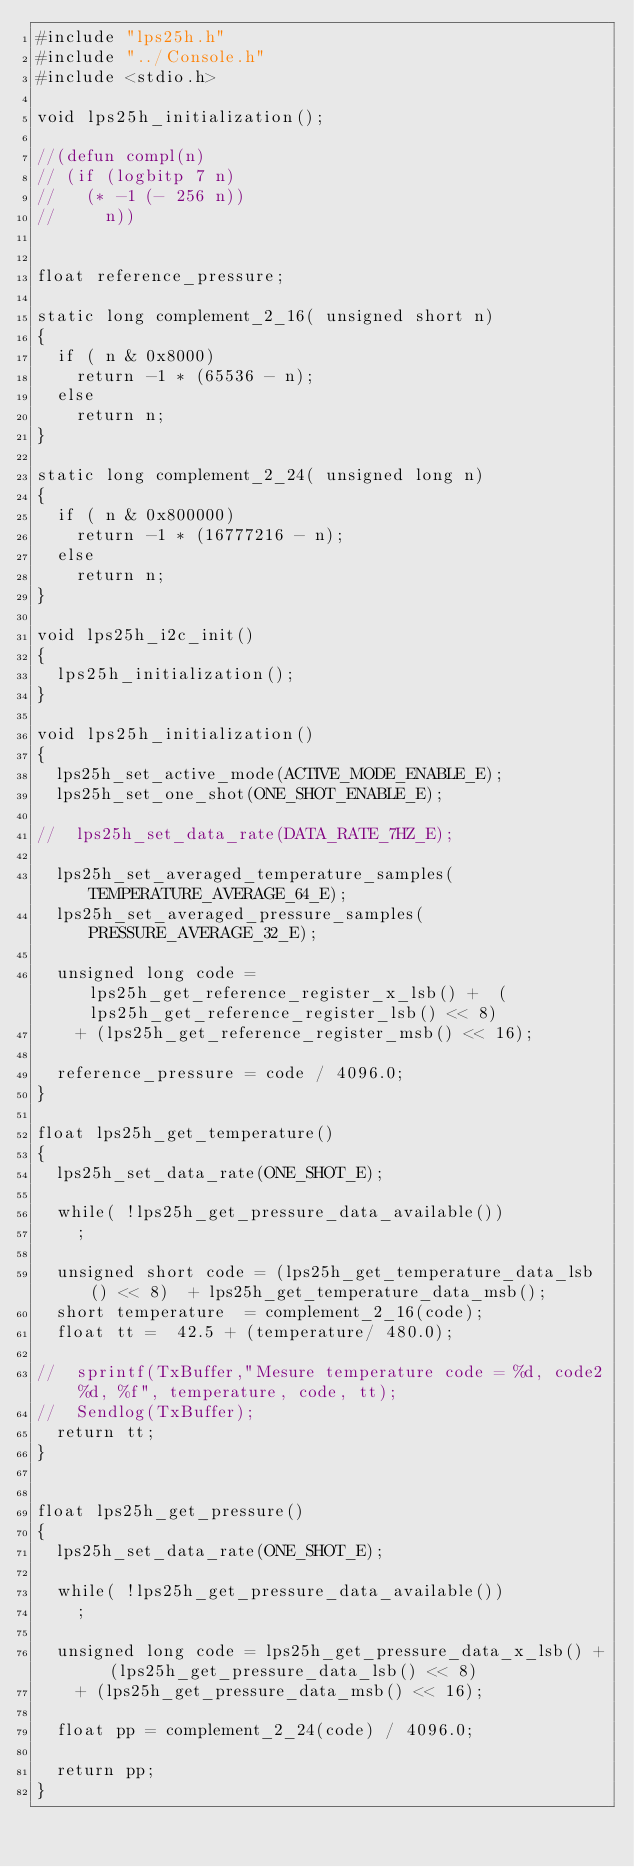Convert code to text. <code><loc_0><loc_0><loc_500><loc_500><_C_>#include "lps25h.h"
#include "../Console.h"
#include <stdio.h>

void lps25h_initialization();

//(defun compl(n)
// (if (logbitp 7 n)
//   (* -1 (- 256 n))
//     n))


float reference_pressure;

static long complement_2_16( unsigned short n)
{
  if ( n & 0x8000)
    return -1 * (65536 - n);
  else
    return n;
}

static long complement_2_24( unsigned long n)
{
  if ( n & 0x800000)
    return -1 * (16777216 - n);
  else
    return n;
}

void lps25h_i2c_init()
{
  lps25h_initialization();
}

void lps25h_initialization()
{
  lps25h_set_active_mode(ACTIVE_MODE_ENABLE_E);
  lps25h_set_one_shot(ONE_SHOT_ENABLE_E);

//  lps25h_set_data_rate(DATA_RATE_7HZ_E);

  lps25h_set_averaged_temperature_samples(TEMPERATURE_AVERAGE_64_E);
  lps25h_set_averaged_pressure_samples(PRESSURE_AVERAGE_32_E);
 
  unsigned long code = lps25h_get_reference_register_x_lsb() +  (lps25h_get_reference_register_lsb() << 8)
    + (lps25h_get_reference_register_msb() << 16);

  reference_pressure = code / 4096.0;
}

float lps25h_get_temperature()
{
  lps25h_set_data_rate(ONE_SHOT_E);

  while( !lps25h_get_pressure_data_available())
    ;

  unsigned short code = (lps25h_get_temperature_data_lsb() << 8)  + lps25h_get_temperature_data_msb();
  short temperature  = complement_2_16(code);
  float tt =  42.5 + (temperature/ 480.0);

//  sprintf(TxBuffer,"Mesure temperature code = %d, code2 %d, %f", temperature, code, tt);
//  Sendlog(TxBuffer); 
  return tt;
}


float lps25h_get_pressure()
{
  lps25h_set_data_rate(ONE_SHOT_E);
  
  while( !lps25h_get_pressure_data_available())
    ;
  
  unsigned long code = lps25h_get_pressure_data_x_lsb() +  (lps25h_get_pressure_data_lsb() << 8)
    + (lps25h_get_pressure_data_msb() << 16);

  float pp = complement_2_24(code) / 4096.0;
  
  return pp;
}


</code> 